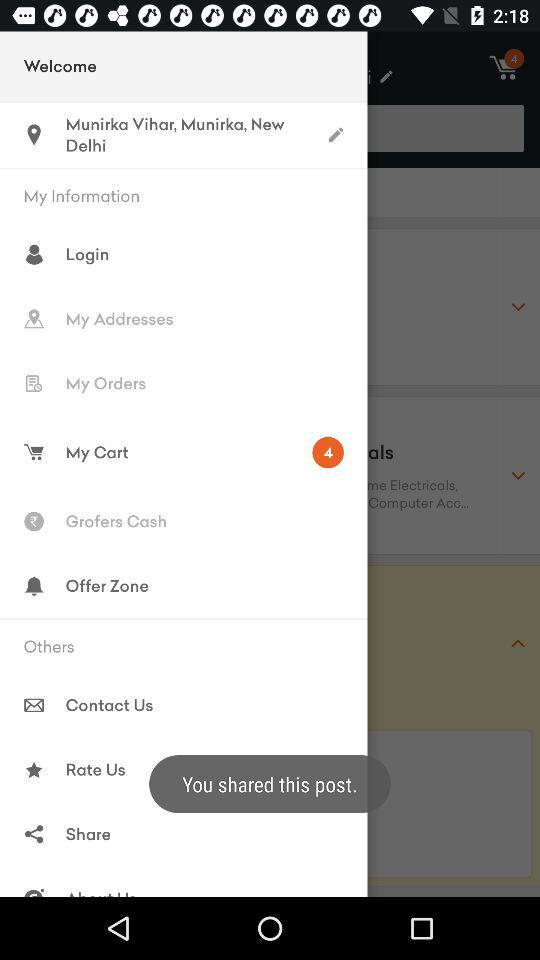Which location is entered? The entered location is Munirka Vihar, Munirka, New Delhi. 